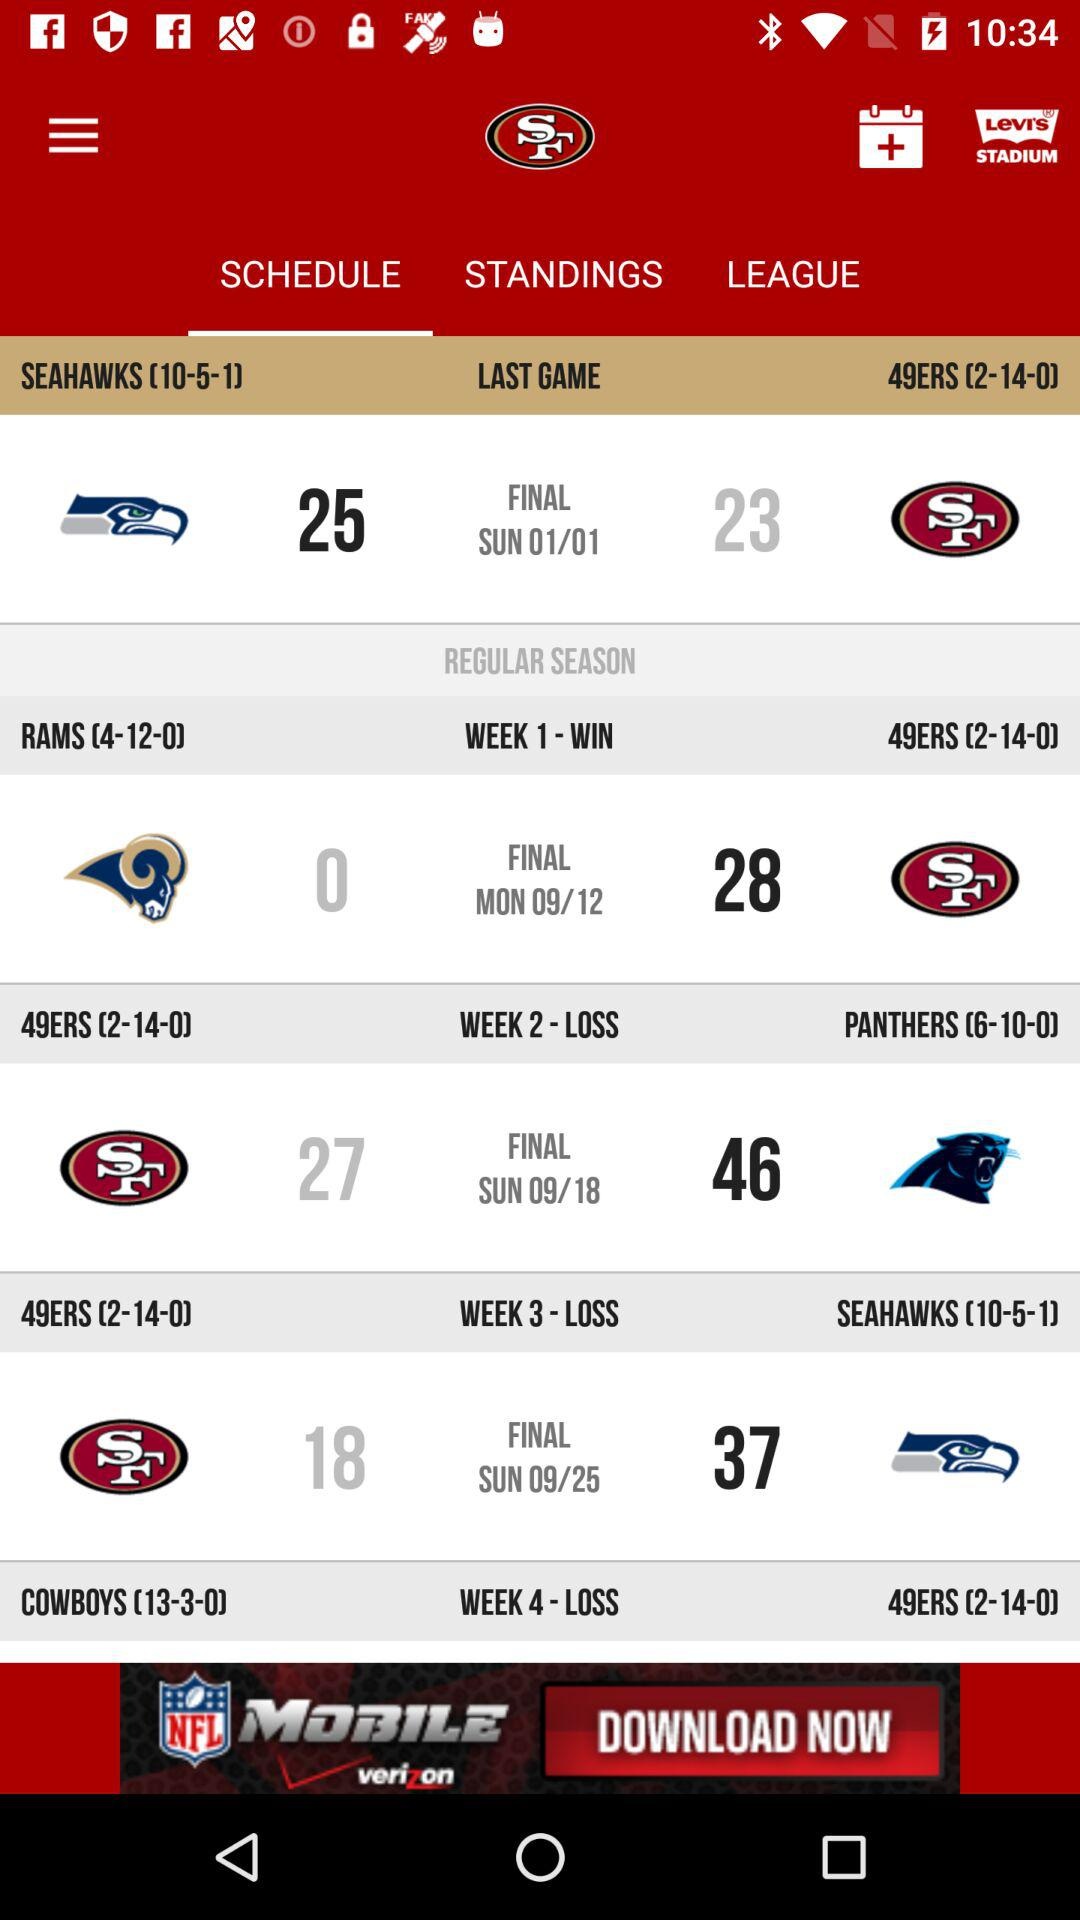What is the result of the match played in week 4? The result of week 4 is "LOSS". 